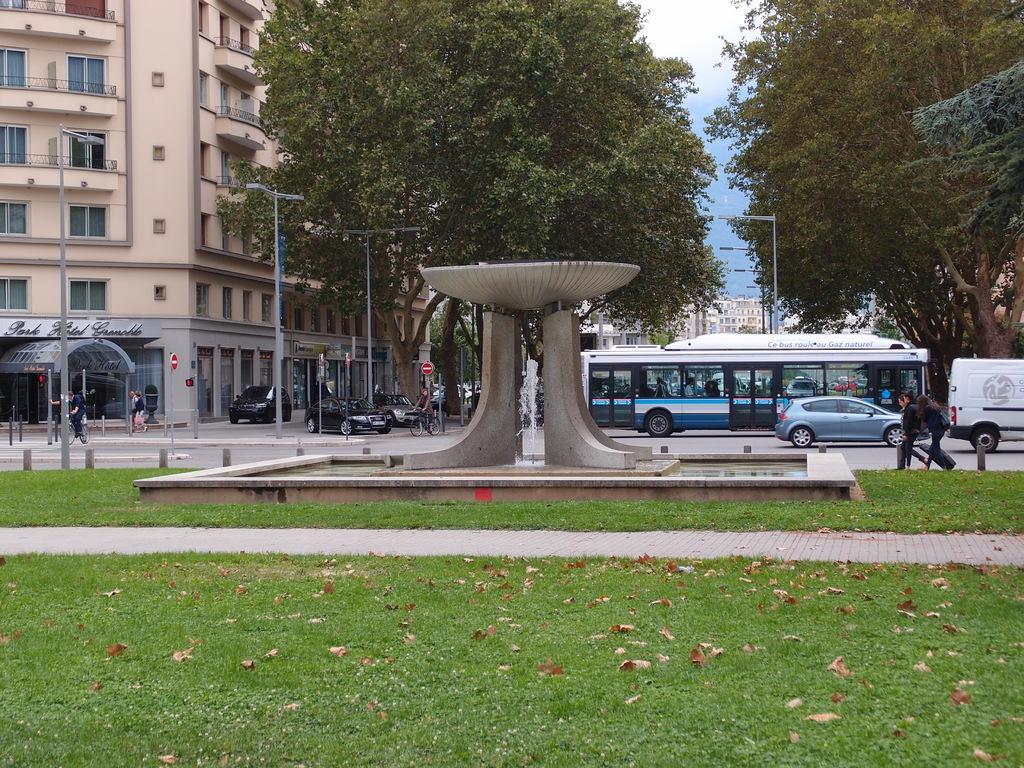How would you summarize this image in a sentence or two? In this picture I can see there is a walkway, a fountain and there is grass on the floor and there are few vehicles moving on the road and there is a building on to left and there are trees and street light poles and the sky is clear. 